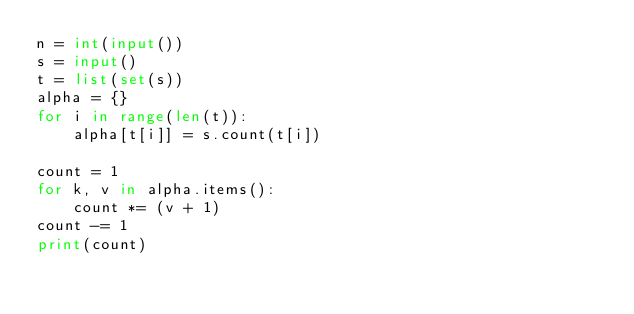Convert code to text. <code><loc_0><loc_0><loc_500><loc_500><_Python_>n = int(input())
s = input()
t = list(set(s))
alpha = {}
for i in range(len(t)):
    alpha[t[i]] = s.count(t[i])

count = 1
for k, v in alpha.items():
    count *= (v + 1)
count -= 1
print(count)</code> 